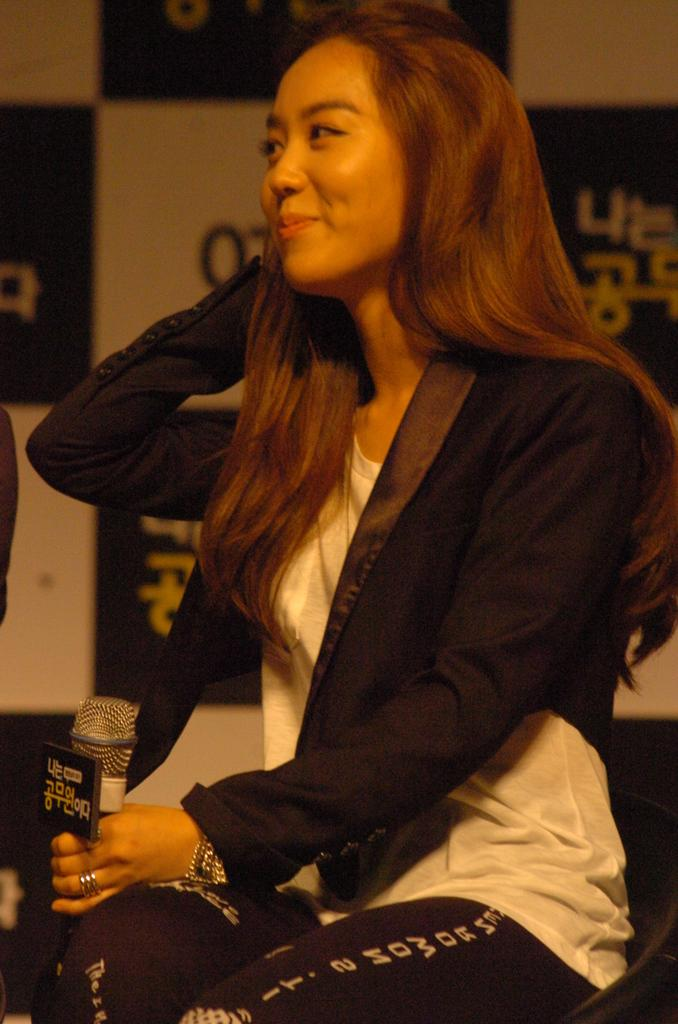Who is present in the image? There is a woman in the image. What is the woman doing in the image? The woman is sitting in the image. What object is the woman holding in her hand? The woman is holding a microphone in her hand. What can be seen in the distance in the image? There is a hoarding in the background of the image. What type of railway is visible in the image? There is no railway present in the image. Is there a band playing in the background of the image? There is no band present in the image. 